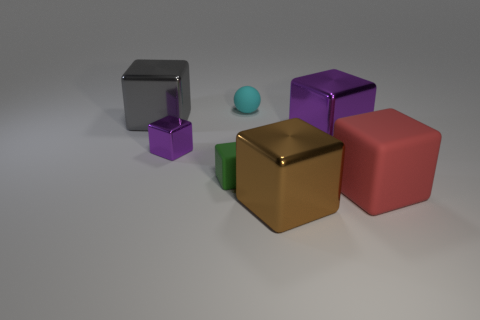Subtract all big gray blocks. How many blocks are left? 5 Subtract all green cubes. How many cubes are left? 5 Subtract all brown cubes. Subtract all red balls. How many cubes are left? 5 Add 2 brown cubes. How many objects exist? 9 Subtract all spheres. How many objects are left? 6 Subtract 0 yellow balls. How many objects are left? 7 Subtract all small yellow cubes. Subtract all large purple metallic cubes. How many objects are left? 6 Add 4 tiny matte blocks. How many tiny matte blocks are left? 5 Add 6 big blue matte spheres. How many big blue matte spheres exist? 6 